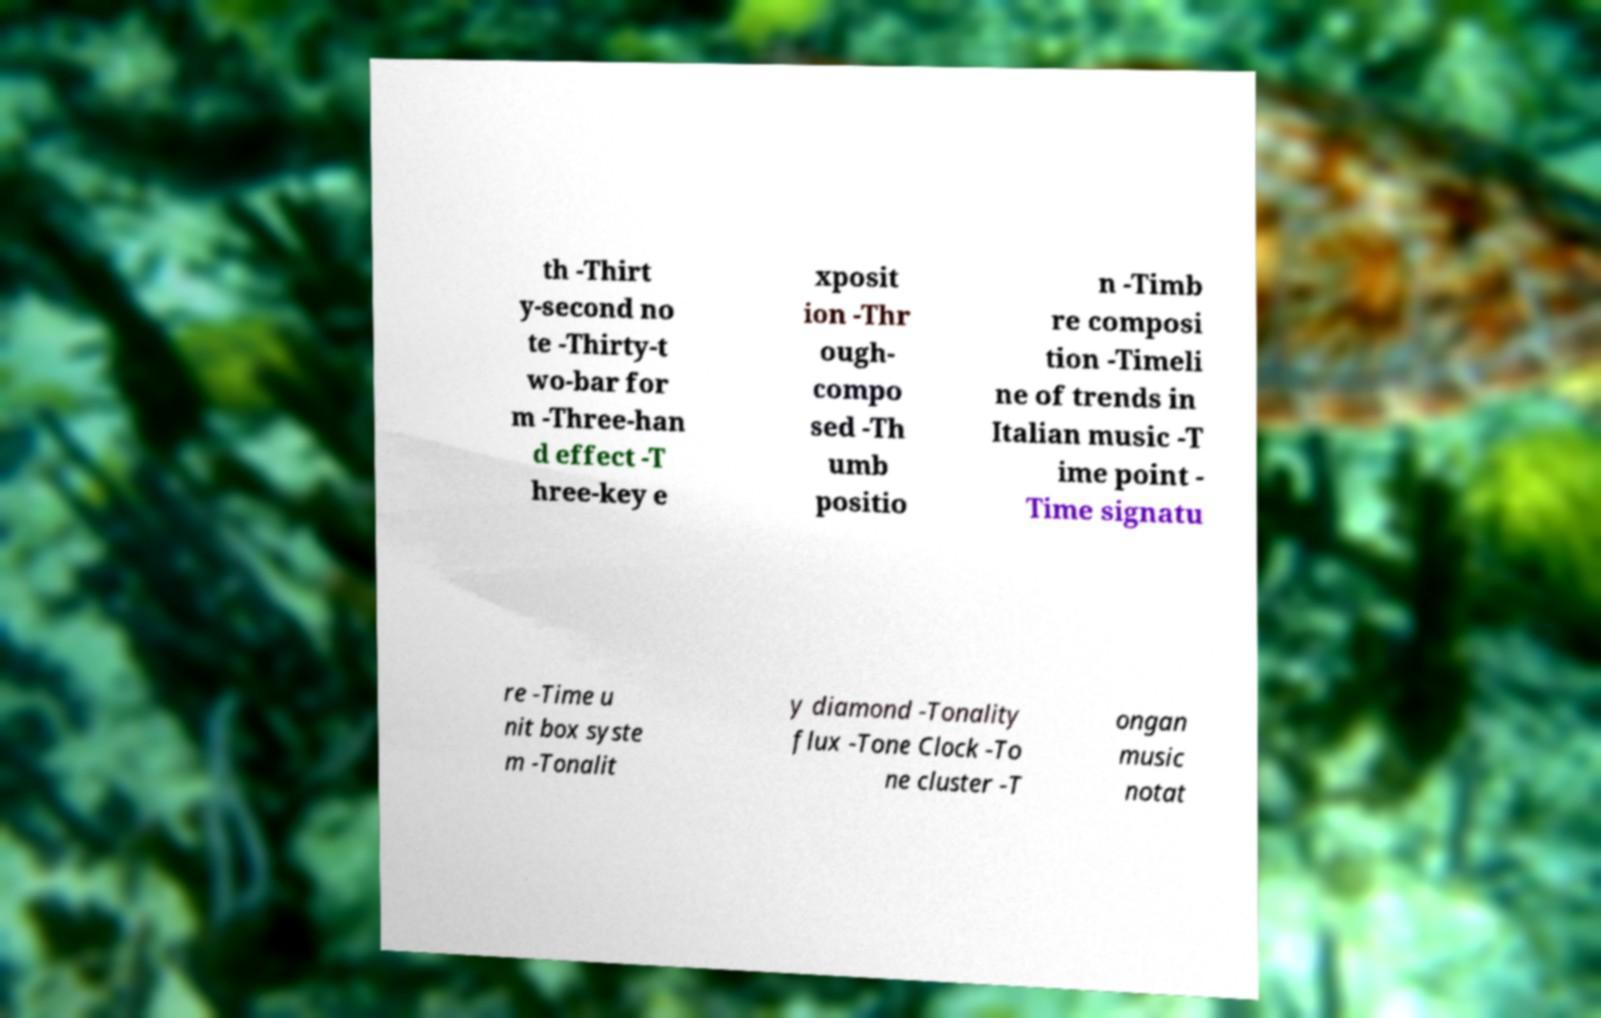What messages or text are displayed in this image? I need them in a readable, typed format. th -Thirt y-second no te -Thirty-t wo-bar for m -Three-han d effect -T hree-key e xposit ion -Thr ough- compo sed -Th umb positio n -Timb re composi tion -Timeli ne of trends in Italian music -T ime point - Time signatu re -Time u nit box syste m -Tonalit y diamond -Tonality flux -Tone Clock -To ne cluster -T ongan music notat 